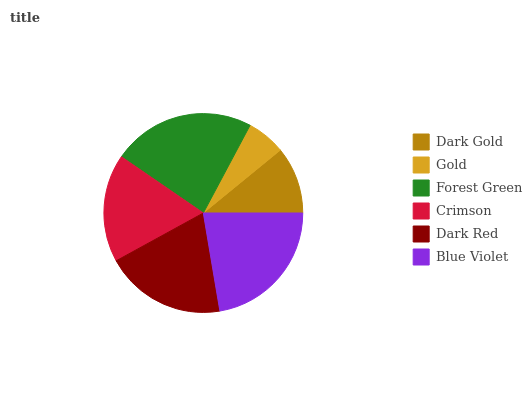Is Gold the minimum?
Answer yes or no. Yes. Is Forest Green the maximum?
Answer yes or no. Yes. Is Forest Green the minimum?
Answer yes or no. No. Is Gold the maximum?
Answer yes or no. No. Is Forest Green greater than Gold?
Answer yes or no. Yes. Is Gold less than Forest Green?
Answer yes or no. Yes. Is Gold greater than Forest Green?
Answer yes or no. No. Is Forest Green less than Gold?
Answer yes or no. No. Is Dark Red the high median?
Answer yes or no. Yes. Is Crimson the low median?
Answer yes or no. Yes. Is Dark Gold the high median?
Answer yes or no. No. Is Dark Red the low median?
Answer yes or no. No. 